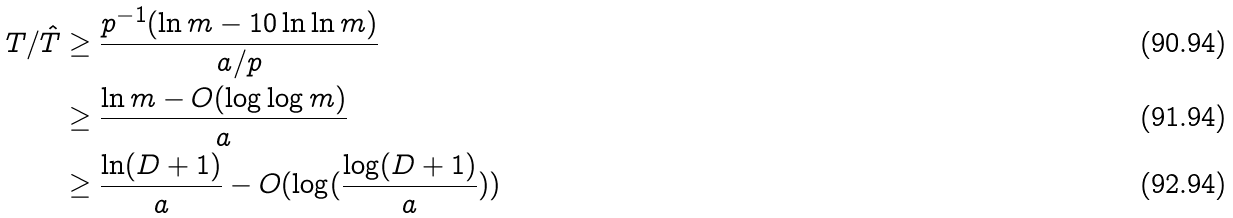<formula> <loc_0><loc_0><loc_500><loc_500>T / \hat { T } & \geq \frac { p ^ { - 1 } ( \ln m - 1 0 \ln \ln m ) } { a / p } \\ & \geq \frac { \ln m - O ( \log \log m ) } { a } \\ & \geq \frac { \ln ( D + 1 ) } { a } - O ( \log ( \frac { \log ( D + 1 ) } { a } ) )</formula> 